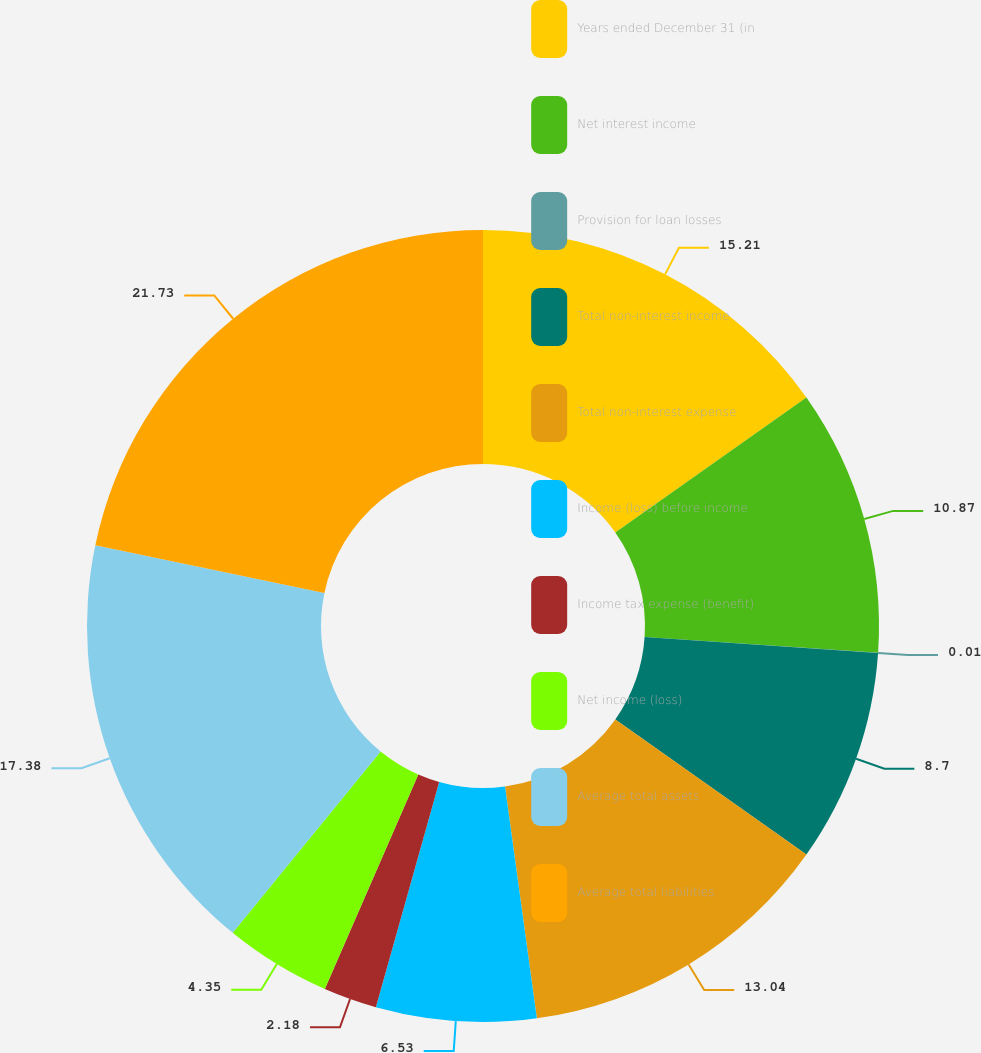Convert chart to OTSL. <chart><loc_0><loc_0><loc_500><loc_500><pie_chart><fcel>Years ended December 31 (in<fcel>Net interest income<fcel>Provision for loan losses<fcel>Total non-interest income<fcel>Total non-interest expense<fcel>Income (loss) before income<fcel>Income tax expense (benefit)<fcel>Net income (loss)<fcel>Average total assets<fcel>Average total liabilities<nl><fcel>15.21%<fcel>10.87%<fcel>0.01%<fcel>8.7%<fcel>13.04%<fcel>6.53%<fcel>2.18%<fcel>4.35%<fcel>17.38%<fcel>21.73%<nl></chart> 